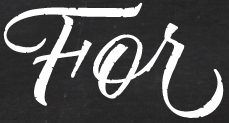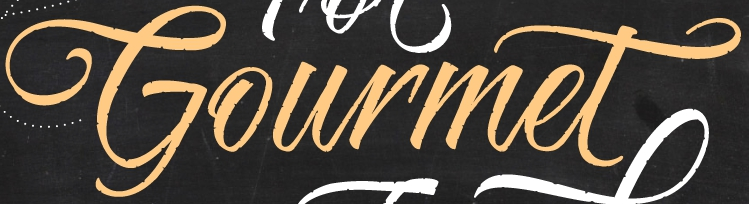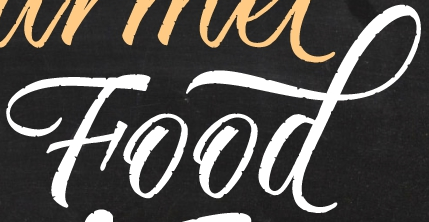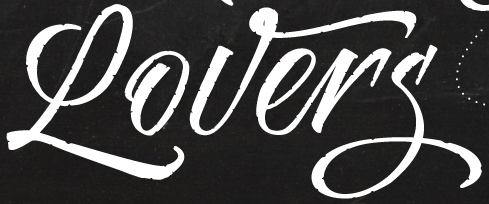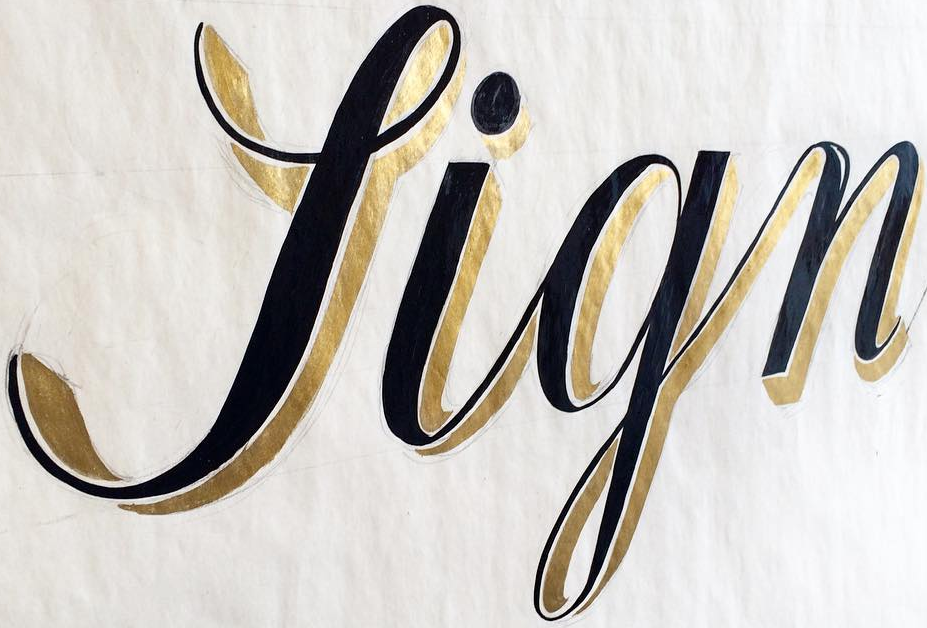What text appears in these images from left to right, separated by a semicolon? For; Gourmet; Food; Lovers; Sign 